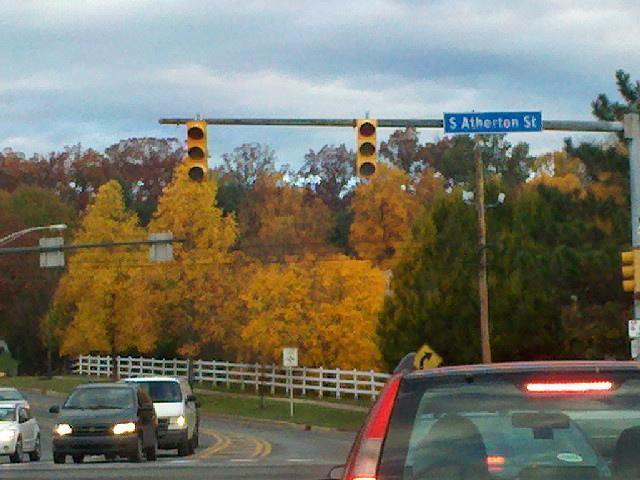How many cars are in the picture?
Give a very brief answer. 4. 